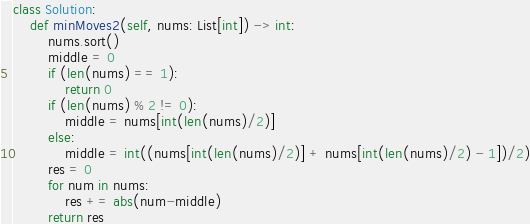Convert code to text. <code><loc_0><loc_0><loc_500><loc_500><_Python_>class Solution:
    def minMoves2(self, nums: List[int]) -> int:
        nums.sort()
        middle = 0
        if (len(nums) == 1):
            return 0
        if (len(nums) % 2 != 0):
            middle = nums[int(len(nums)/2)]
        else:
            middle = int((nums[int(len(nums)/2)] + nums[int(len(nums)/2) - 1])/2)
        res = 0
        for num in nums:
            res += abs(num-middle)
        return res</code> 